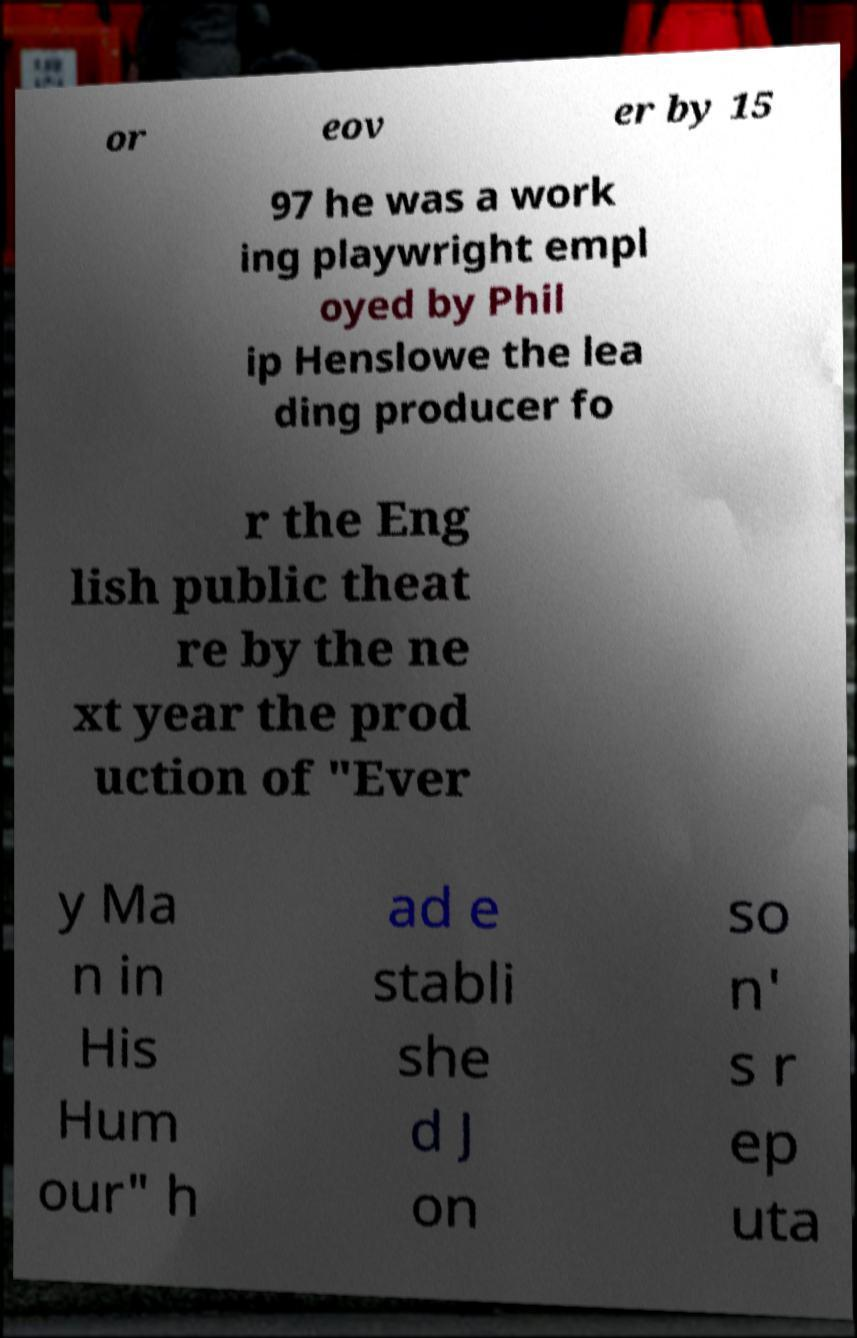Please read and relay the text visible in this image. What does it say? or eov er by 15 97 he was a work ing playwright empl oyed by Phil ip Henslowe the lea ding producer fo r the Eng lish public theat re by the ne xt year the prod uction of "Ever y Ma n in His Hum our" h ad e stabli she d J on so n' s r ep uta 